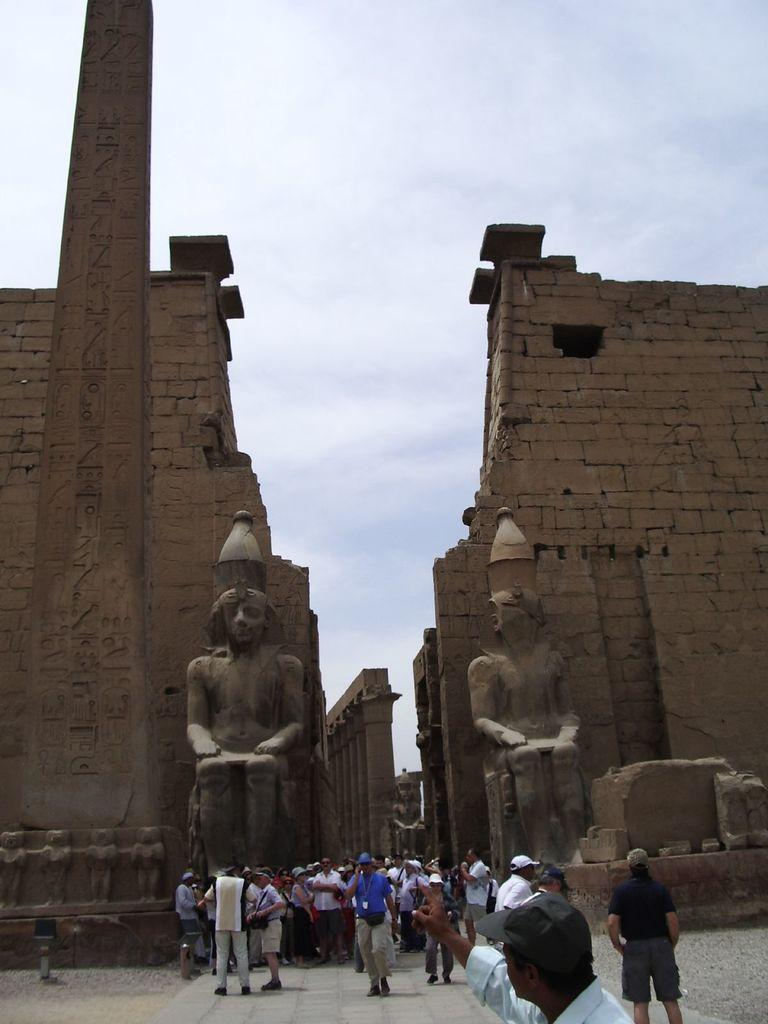How many people are in the group visible in the image? There is a group of persons in the image, but the exact number cannot be determined from the provided facts. What can be seen behind the persons in the image? There are sculptures visible behind the persons in the image. What architectural features are present in the background of the image? There are walls and pillars in the background of the image. What is visible at the top of the image? The sky is visible at the top of the image. What type of basketball game is being played in the image? There is no basketball game present in the image; it features a group of persons with sculptures, walls, pillars, and a visible sky in the background. What caption would best describe the image? The provided facts do not include any information about a caption for the image, so it is not possible to determine the best caption. 